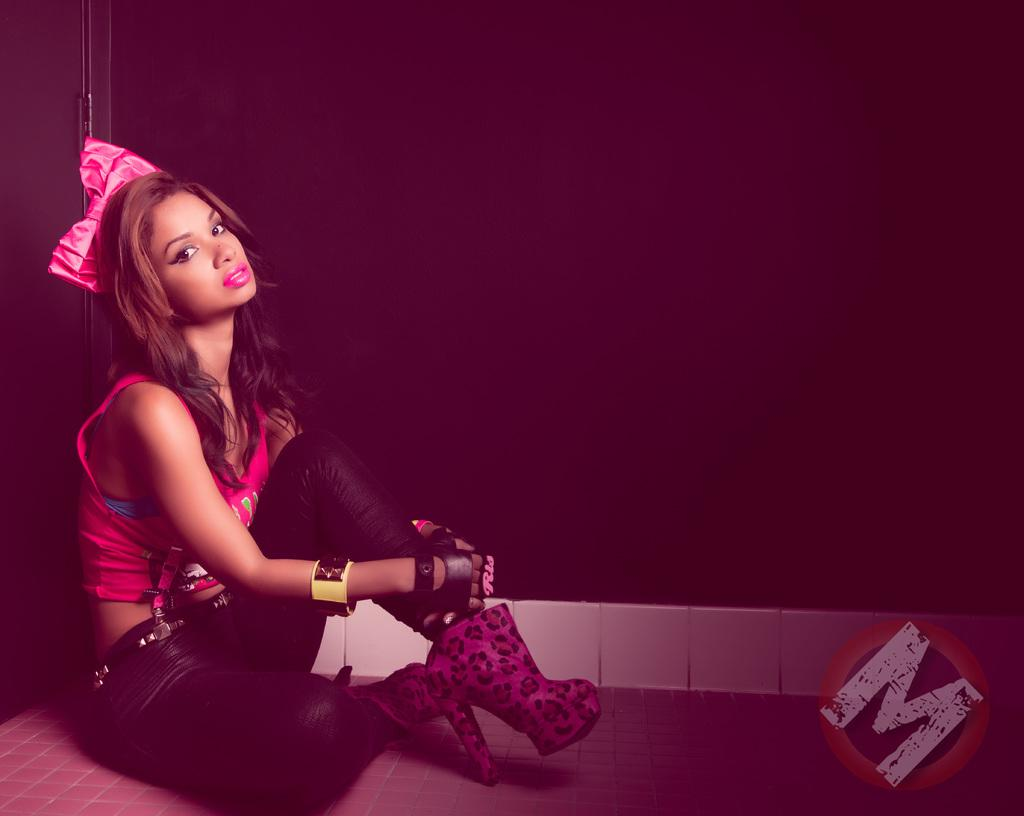Who is present in the image? There is a woman in the image. What is the woman doing in the image? The woman is sitting on the ground. What can be seen in the background of the image? There is a wall in the background of the image. What type of lettuce is being used for the activity in the image? There is no lettuce or activity involving lettuce present in the image. 